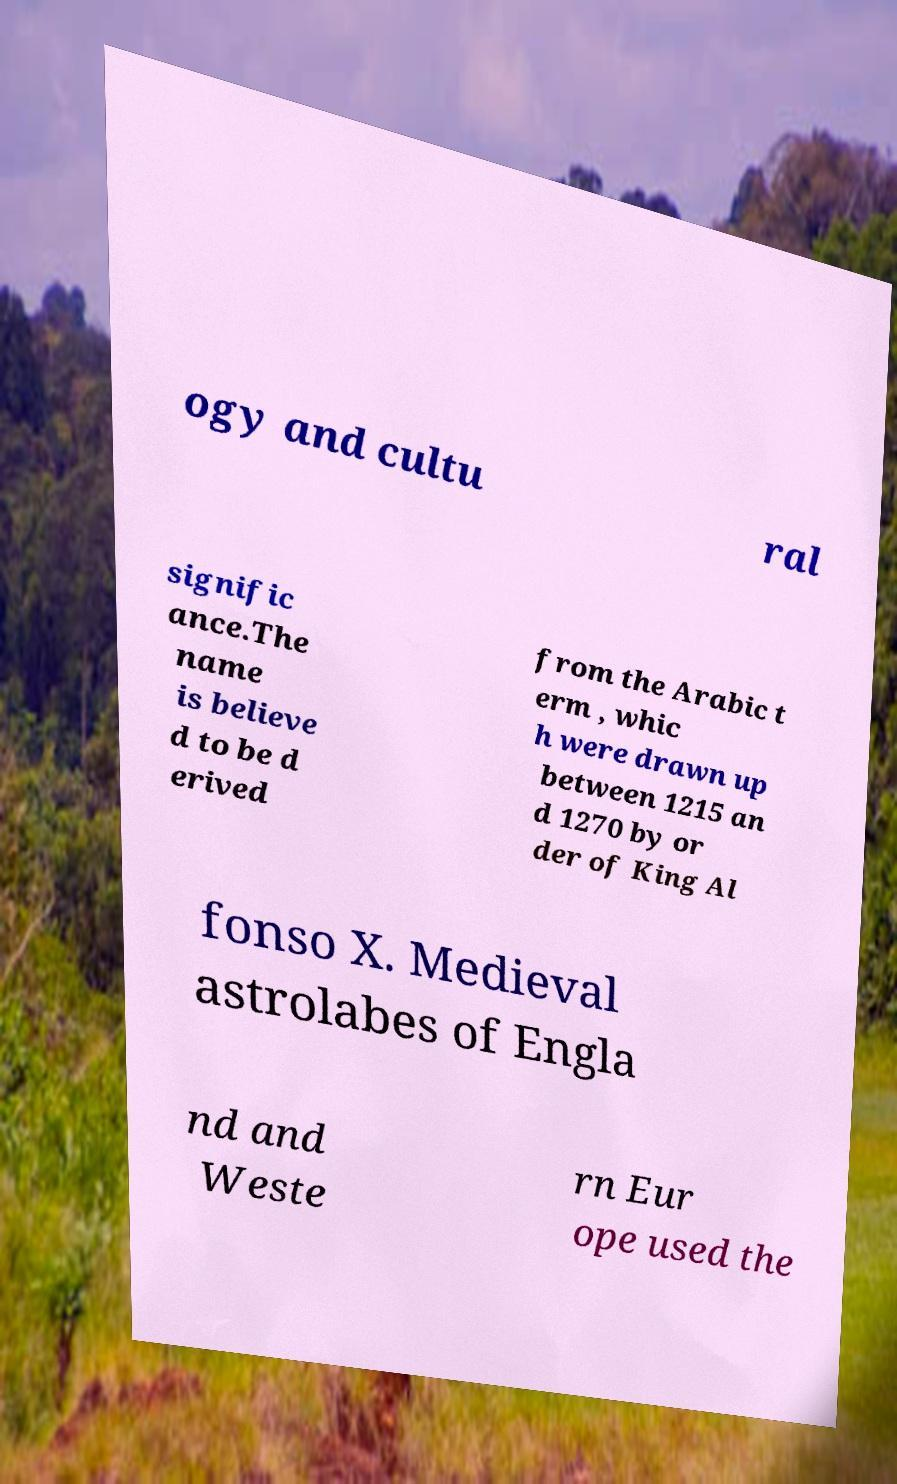There's text embedded in this image that I need extracted. Can you transcribe it verbatim? ogy and cultu ral signific ance.The name is believe d to be d erived from the Arabic t erm , whic h were drawn up between 1215 an d 1270 by or der of King Al fonso X. Medieval astrolabes of Engla nd and Weste rn Eur ope used the 